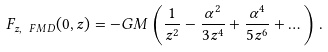Convert formula to latex. <formula><loc_0><loc_0><loc_500><loc_500>F _ { z , \ F M D } ( 0 , z ) = - G M \left ( \frac { 1 } { z ^ { 2 } } - \frac { \alpha ^ { 2 } } { 3 z ^ { 4 } } + \frac { \alpha ^ { 4 } } { 5 z ^ { 6 } } + \dots \right ) .</formula> 